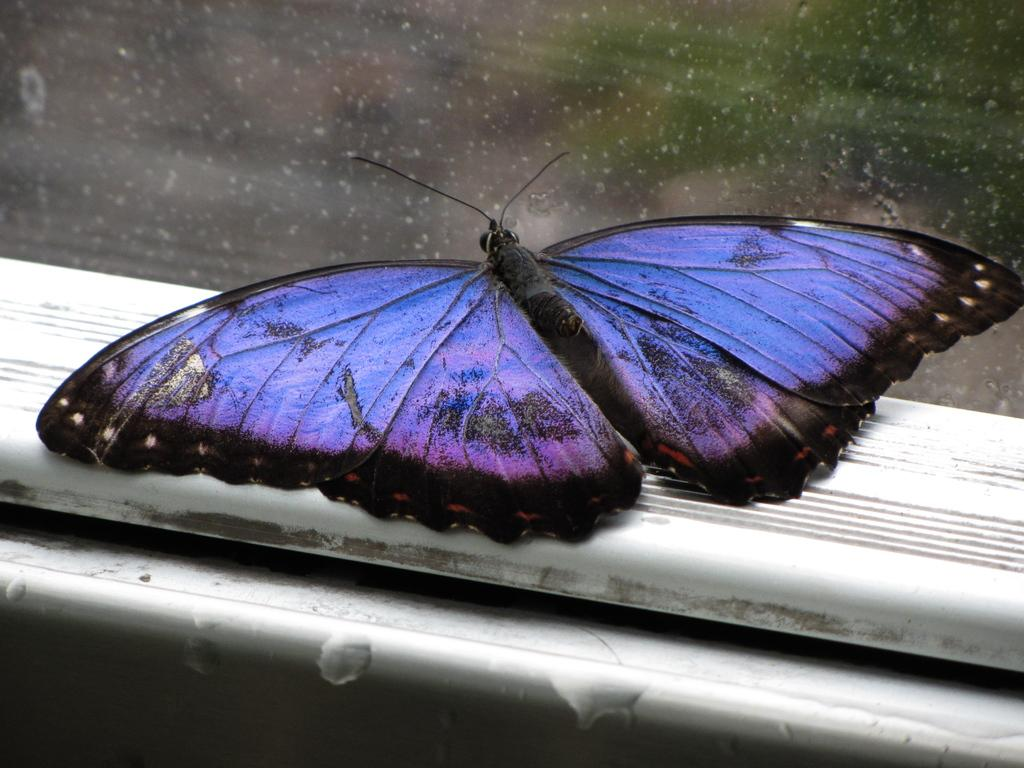What is the main subject in the center of the image? There is a butterfly in the center of the image. What type of meeting is taking place in the image? There is no meeting present in the image; it features a butterfly in the center. What is the guide's role in the image? There is no guide present in the image; it features a butterfly in the center. 